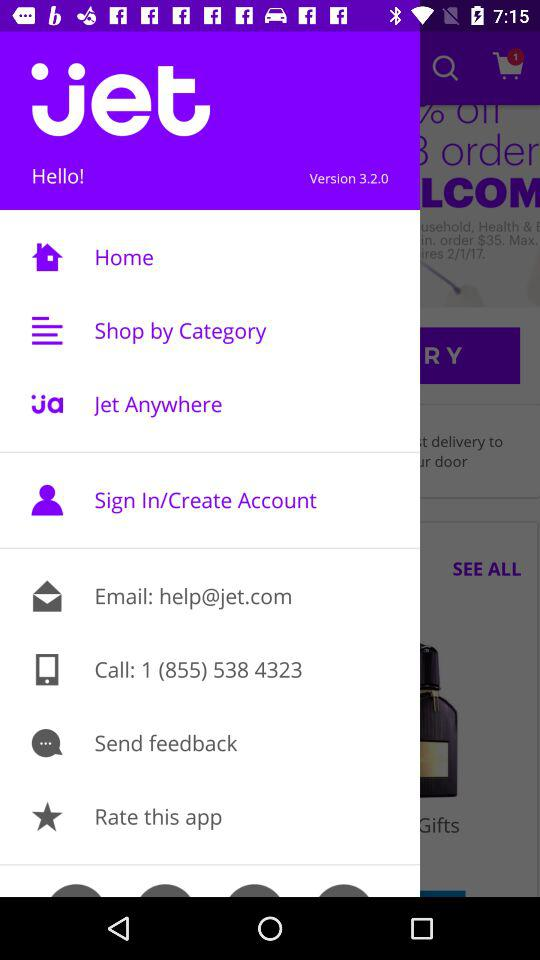What version of the application is this? This is version 3.2.0 of the application. 